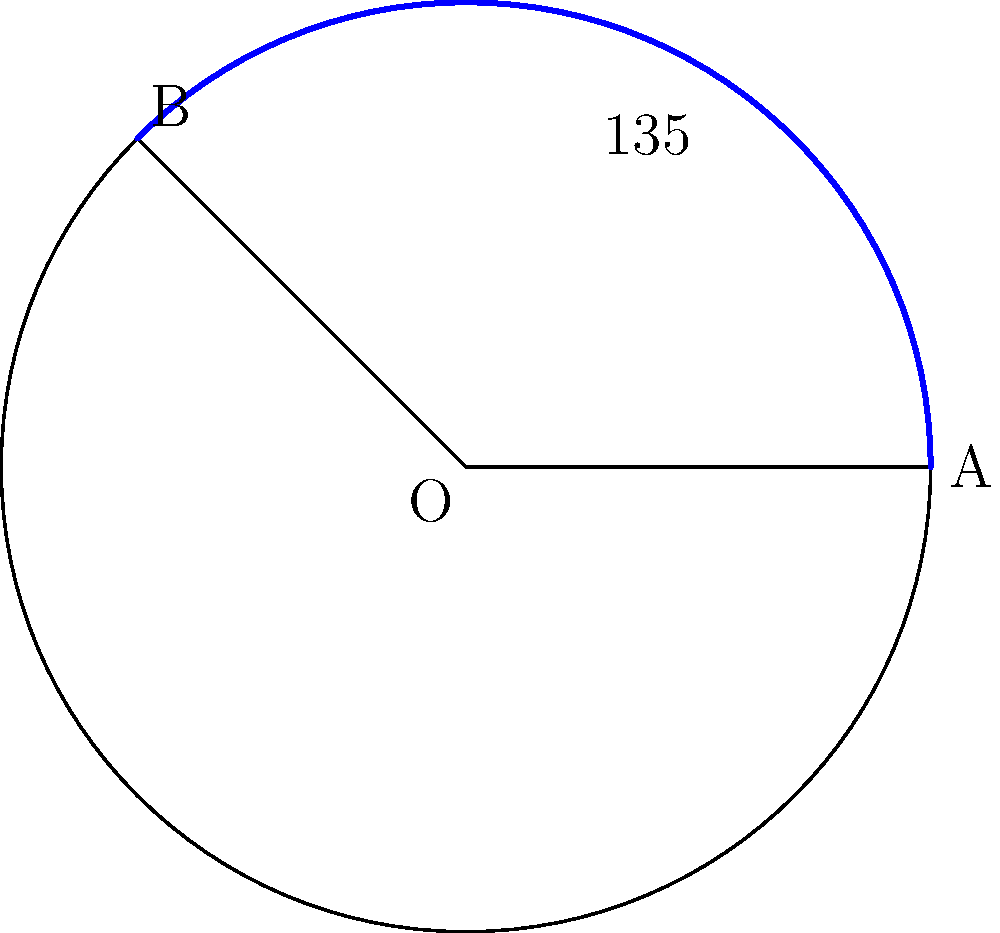As a movie producer adapting a novel into a film, you've decided to represent the pacing of key plot points using a circle. The entire story arc is represented by a full circle with radius 6 units. If the first act of your film covers $135°$ of this circle, what is the length of the arc representing this act? Round your answer to two decimal places. To solve this problem, we'll use the formula for arc length and follow these steps:

1) The formula for arc length is:
   $s = r\theta$
   where $s$ is the arc length, $r$ is the radius, and $\theta$ is the central angle in radians.

2) We're given the angle in degrees ($135°$), so we need to convert it to radians:
   $\theta = 135° \times \frac{\pi}{180°} = \frac{3\pi}{4}$ radians

3) We're given the radius $r = 6$ units.

4) Now we can plug these values into our formula:
   $s = r\theta = 6 \times \frac{3\pi}{4} = \frac{9\pi}{2}$

5) Let's calculate this:
   $\frac{9\pi}{2} \approx 14.1371653...$

6) Rounding to two decimal places:
   $14.14$ units
Answer: $14.14$ units 